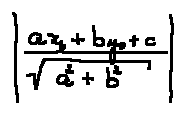<formula> <loc_0><loc_0><loc_500><loc_500>| \frac { a x _ { 0 } + b y _ { 0 } + c } { \sqrt { a ^ { 2 } + b ^ { 2 } } } |</formula> 